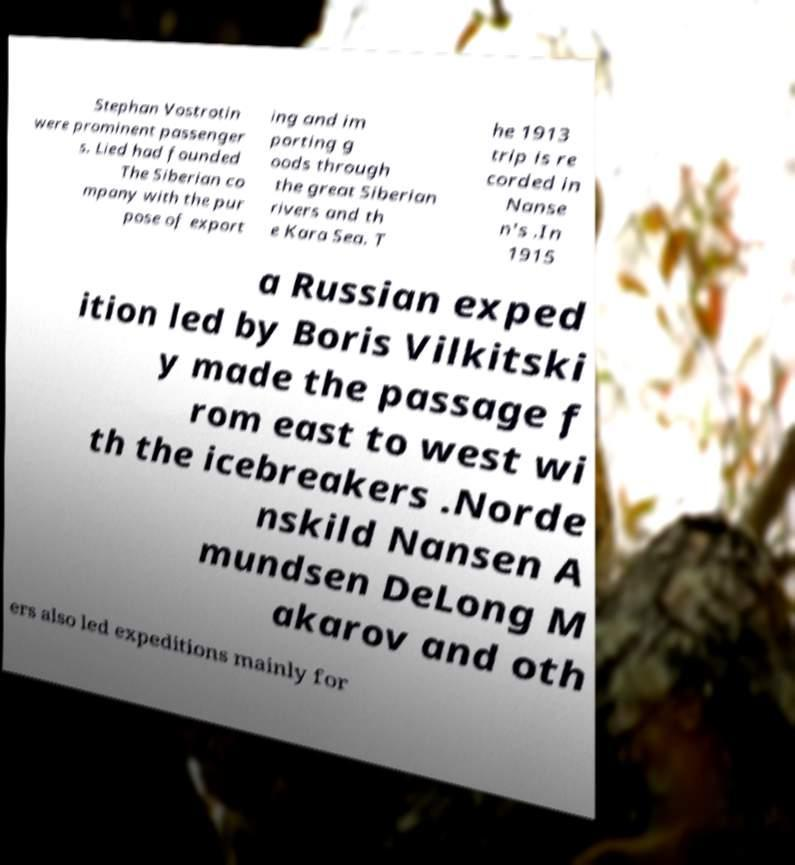Could you assist in decoding the text presented in this image and type it out clearly? Stephan Vostrotin were prominent passenger s. Lied had founded The Siberian co mpany with the pur pose of export ing and im porting g oods through the great Siberian rivers and th e Kara Sea. T he 1913 trip is re corded in Nanse n's .In 1915 a Russian exped ition led by Boris Vilkitski y made the passage f rom east to west wi th the icebreakers .Norde nskild Nansen A mundsen DeLong M akarov and oth ers also led expeditions mainly for 